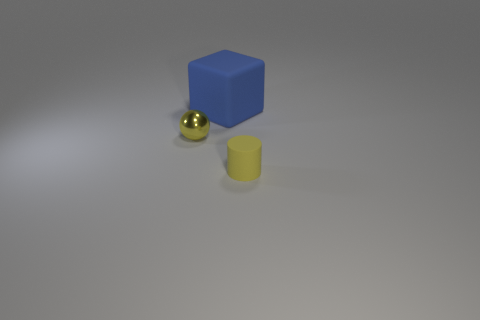Add 3 tiny green matte cubes. How many objects exist? 6 Subtract all cubes. How many objects are left? 2 Subtract all yellow objects. Subtract all tiny metallic spheres. How many objects are left? 0 Add 1 big blue rubber things. How many big blue rubber things are left? 2 Add 3 tiny rubber objects. How many tiny rubber objects exist? 4 Subtract 0 gray cubes. How many objects are left? 3 Subtract all blue balls. Subtract all cyan blocks. How many balls are left? 1 